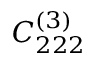<formula> <loc_0><loc_0><loc_500><loc_500>C _ { 2 2 2 } ^ { ( 3 ) }</formula> 